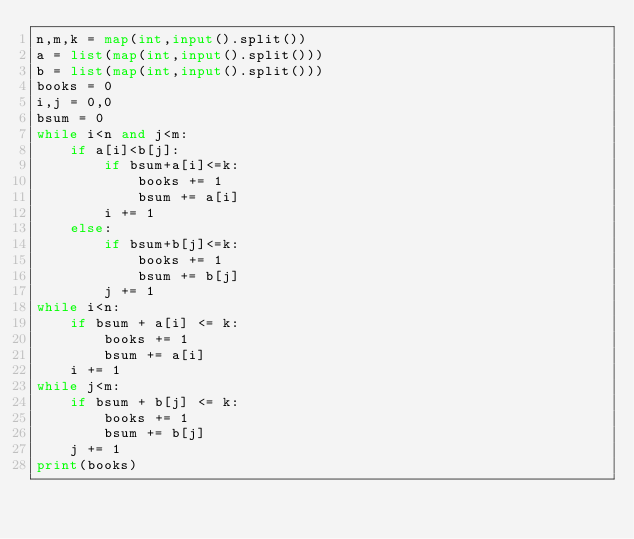<code> <loc_0><loc_0><loc_500><loc_500><_Python_>n,m,k = map(int,input().split())
a = list(map(int,input().split()))
b = list(map(int,input().split()))
books = 0
i,j = 0,0
bsum = 0
while i<n and j<m:
    if a[i]<b[j]:
        if bsum+a[i]<=k:
            books += 1
            bsum += a[i]
        i += 1
    else:
        if bsum+b[j]<=k:
            books += 1
            bsum += b[j]
        j += 1
while i<n:
    if bsum + a[i] <= k:
        books += 1
        bsum += a[i]
    i += 1
while j<m:
    if bsum + b[j] <= k:
        books += 1
        bsum += b[j]
    j += 1
print(books)
</code> 